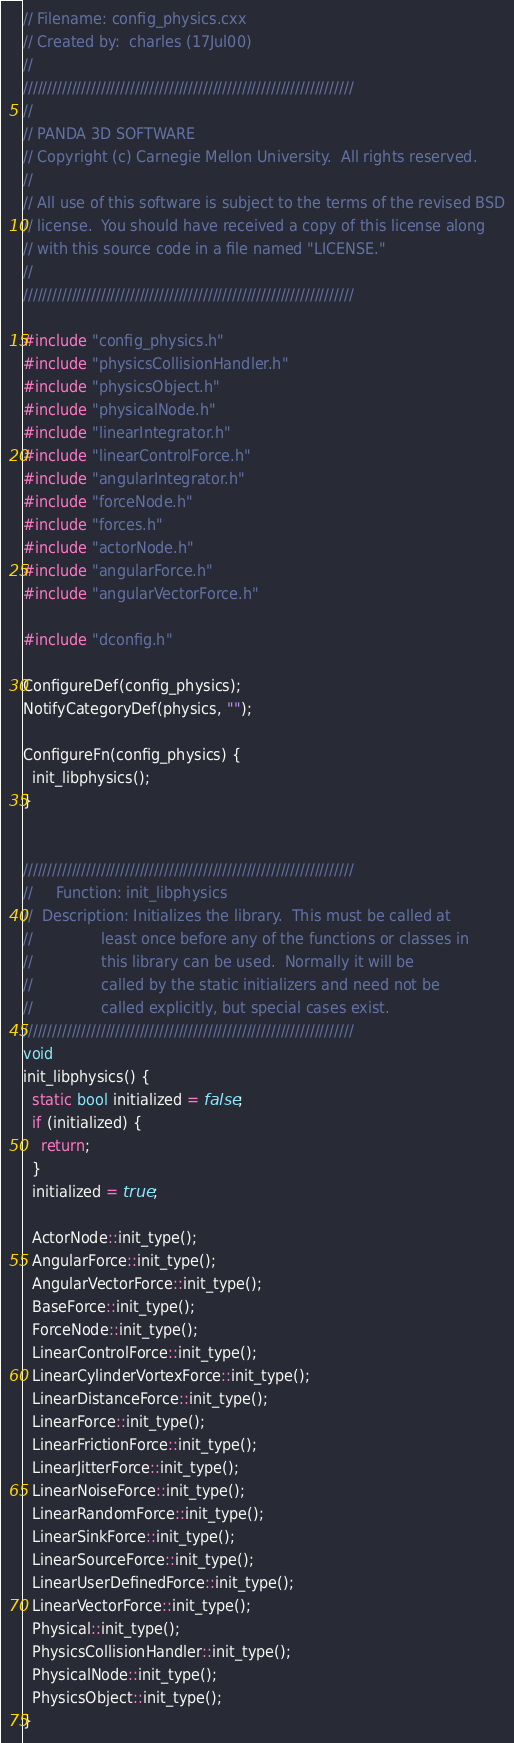Convert code to text. <code><loc_0><loc_0><loc_500><loc_500><_C++_>// Filename: config_physics.cxx
// Created by:  charles (17Jul00)
//
////////////////////////////////////////////////////////////////////
//
// PANDA 3D SOFTWARE
// Copyright (c) Carnegie Mellon University.  All rights reserved.
//
// All use of this software is subject to the terms of the revised BSD
// license.  You should have received a copy of this license along
// with this source code in a file named "LICENSE."
//
////////////////////////////////////////////////////////////////////

#include "config_physics.h"
#include "physicsCollisionHandler.h"
#include "physicsObject.h"
#include "physicalNode.h"
#include "linearIntegrator.h"
#include "linearControlForce.h"
#include "angularIntegrator.h"
#include "forceNode.h"
#include "forces.h"
#include "actorNode.h"
#include "angularForce.h"
#include "angularVectorForce.h"

#include "dconfig.h"

ConfigureDef(config_physics);
NotifyCategoryDef(physics, "");

ConfigureFn(config_physics) {
  init_libphysics();
}


////////////////////////////////////////////////////////////////////
//     Function: init_libphysics
//  Description: Initializes the library.  This must be called at
//               least once before any of the functions or classes in
//               this library can be used.  Normally it will be
//               called by the static initializers and need not be
//               called explicitly, but special cases exist.
////////////////////////////////////////////////////////////////////
void
init_libphysics() {
  static bool initialized = false;
  if (initialized) {
    return;
  }
  initialized = true;

  ActorNode::init_type();
  AngularForce::init_type();
  AngularVectorForce::init_type();
  BaseForce::init_type();
  ForceNode::init_type();
  LinearControlForce::init_type();
  LinearCylinderVortexForce::init_type();
  LinearDistanceForce::init_type();
  LinearForce::init_type();
  LinearFrictionForce::init_type();
  LinearJitterForce::init_type();
  LinearNoiseForce::init_type();
  LinearRandomForce::init_type();
  LinearSinkForce::init_type();
  LinearSourceForce::init_type();
  LinearUserDefinedForce::init_type();
  LinearVectorForce::init_type();
  Physical::init_type();
  PhysicsCollisionHandler::init_type();
  PhysicalNode::init_type();
  PhysicsObject::init_type();
}
</code> 